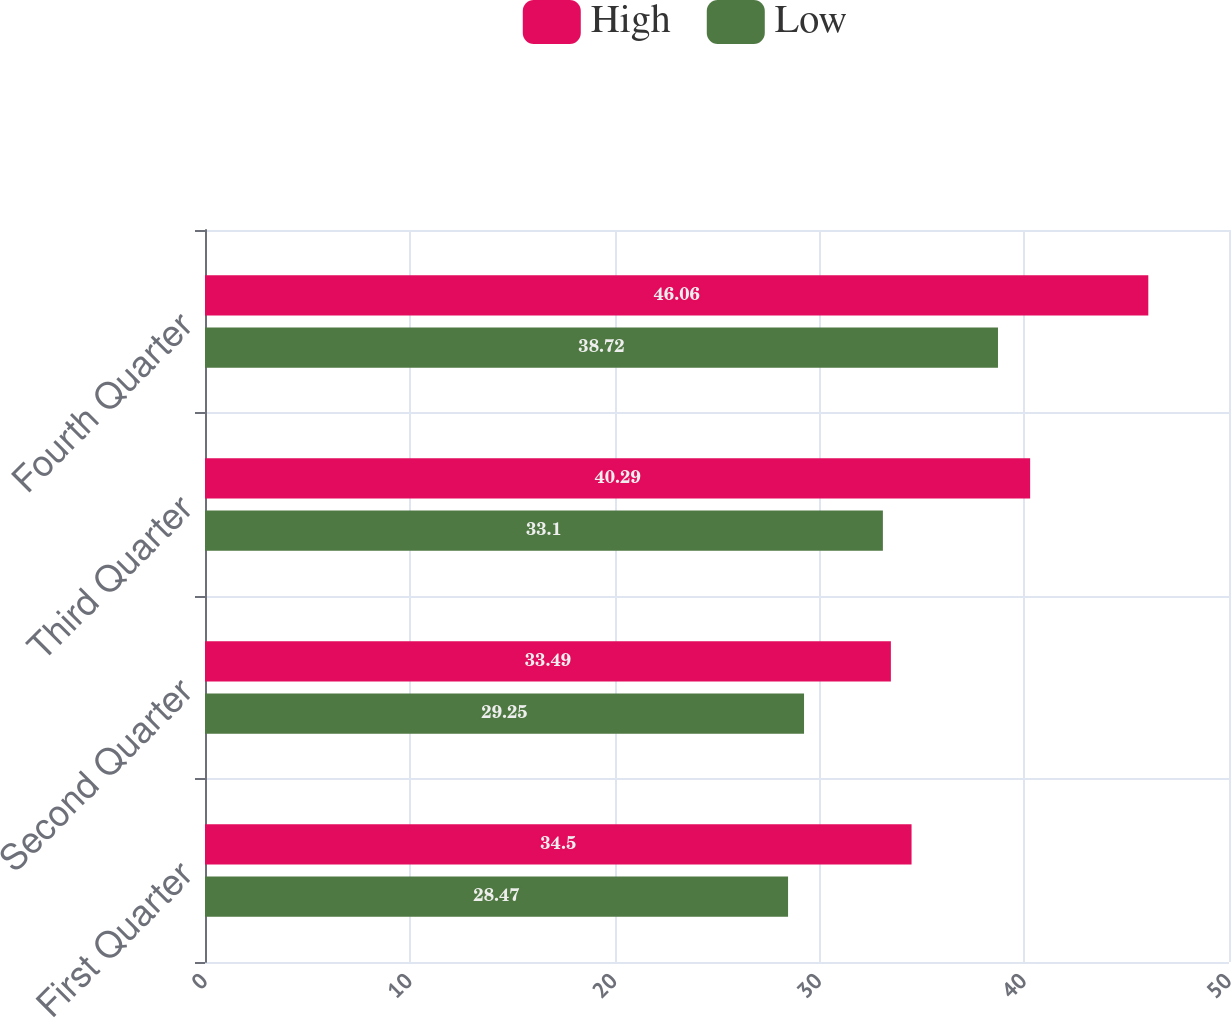<chart> <loc_0><loc_0><loc_500><loc_500><stacked_bar_chart><ecel><fcel>First Quarter<fcel>Second Quarter<fcel>Third Quarter<fcel>Fourth Quarter<nl><fcel>High<fcel>34.5<fcel>33.49<fcel>40.29<fcel>46.06<nl><fcel>Low<fcel>28.47<fcel>29.25<fcel>33.1<fcel>38.72<nl></chart> 